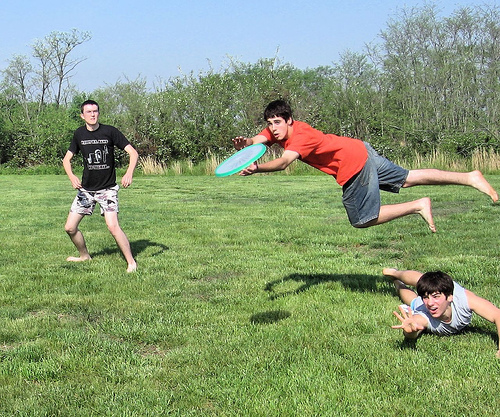Please provide a short description for this region: [0.65, 0.35, 0.81, 0.54]. A boy wearing jean shorts and jumping to catch a frisbee. 